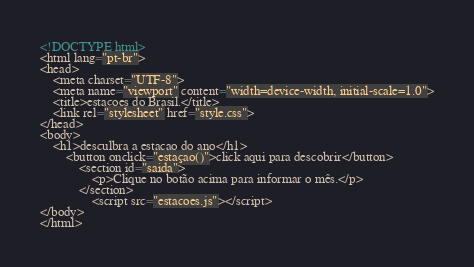<code> <loc_0><loc_0><loc_500><loc_500><_HTML_><!DOCTYPE html>
<html lang="pt-br">
<head>
    <meta charset="UTF-8">
    <meta name="viewport" content="width=device-width, initial-scale=1.0">
    <title>estaçoes do Brasil.</title>
    <link rel="stylesheet" href="style.css">
</head>
<body>
    <h1>desculbra a estacao do ano</h1>
        <button onclick="estaçao()">click aqui para descobrir</button>
            <section id="saida">
                <p>Clique no botão acima para informar o mês.</p>
            </section>
                <script src="estacoes.js"></script>
</body>
</html></code> 